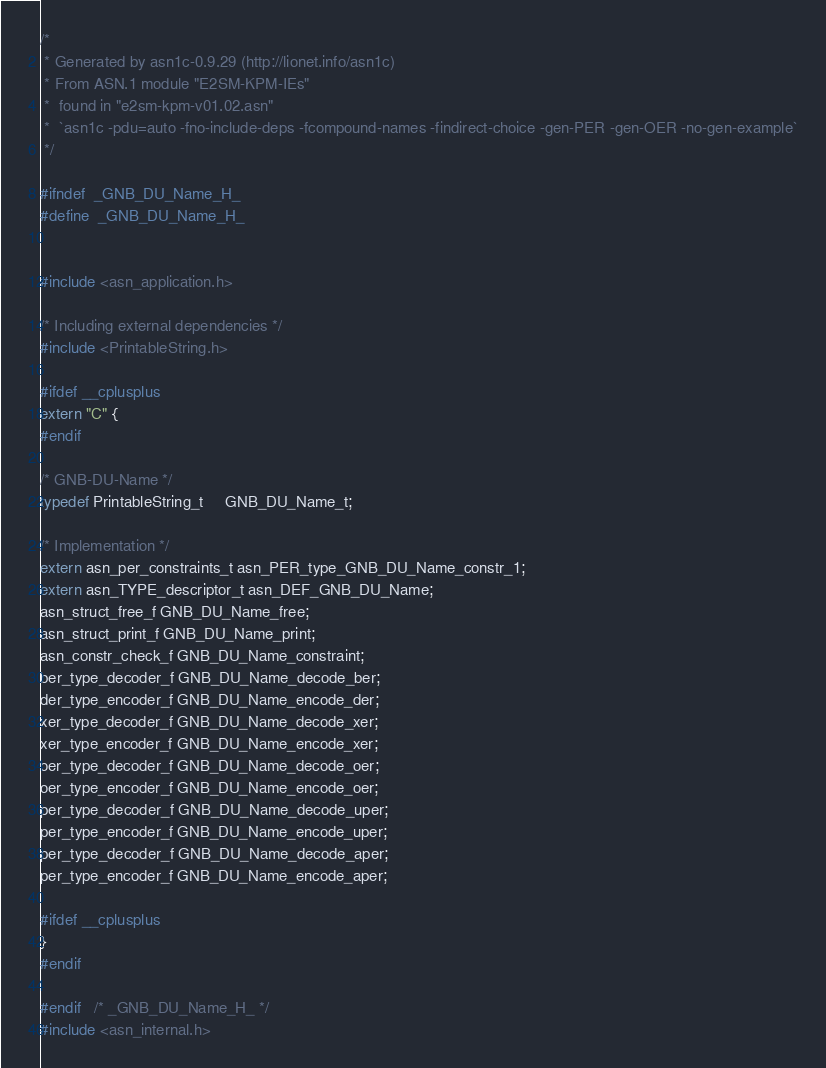Convert code to text. <code><loc_0><loc_0><loc_500><loc_500><_C_>/*
 * Generated by asn1c-0.9.29 (http://lionet.info/asn1c)
 * From ASN.1 module "E2SM-KPM-IEs"
 * 	found in "e2sm-kpm-v01.02.asn"
 * 	`asn1c -pdu=auto -fno-include-deps -fcompound-names -findirect-choice -gen-PER -gen-OER -no-gen-example`
 */

#ifndef	_GNB_DU_Name_H_
#define	_GNB_DU_Name_H_


#include <asn_application.h>

/* Including external dependencies */
#include <PrintableString.h>

#ifdef __cplusplus
extern "C" {
#endif

/* GNB-DU-Name */
typedef PrintableString_t	 GNB_DU_Name_t;

/* Implementation */
extern asn_per_constraints_t asn_PER_type_GNB_DU_Name_constr_1;
extern asn_TYPE_descriptor_t asn_DEF_GNB_DU_Name;
asn_struct_free_f GNB_DU_Name_free;
asn_struct_print_f GNB_DU_Name_print;
asn_constr_check_f GNB_DU_Name_constraint;
ber_type_decoder_f GNB_DU_Name_decode_ber;
der_type_encoder_f GNB_DU_Name_encode_der;
xer_type_decoder_f GNB_DU_Name_decode_xer;
xer_type_encoder_f GNB_DU_Name_encode_xer;
oer_type_decoder_f GNB_DU_Name_decode_oer;
oer_type_encoder_f GNB_DU_Name_encode_oer;
per_type_decoder_f GNB_DU_Name_decode_uper;
per_type_encoder_f GNB_DU_Name_encode_uper;
per_type_decoder_f GNB_DU_Name_decode_aper;
per_type_encoder_f GNB_DU_Name_encode_aper;

#ifdef __cplusplus
}
#endif

#endif	/* _GNB_DU_Name_H_ */
#include <asn_internal.h>
</code> 